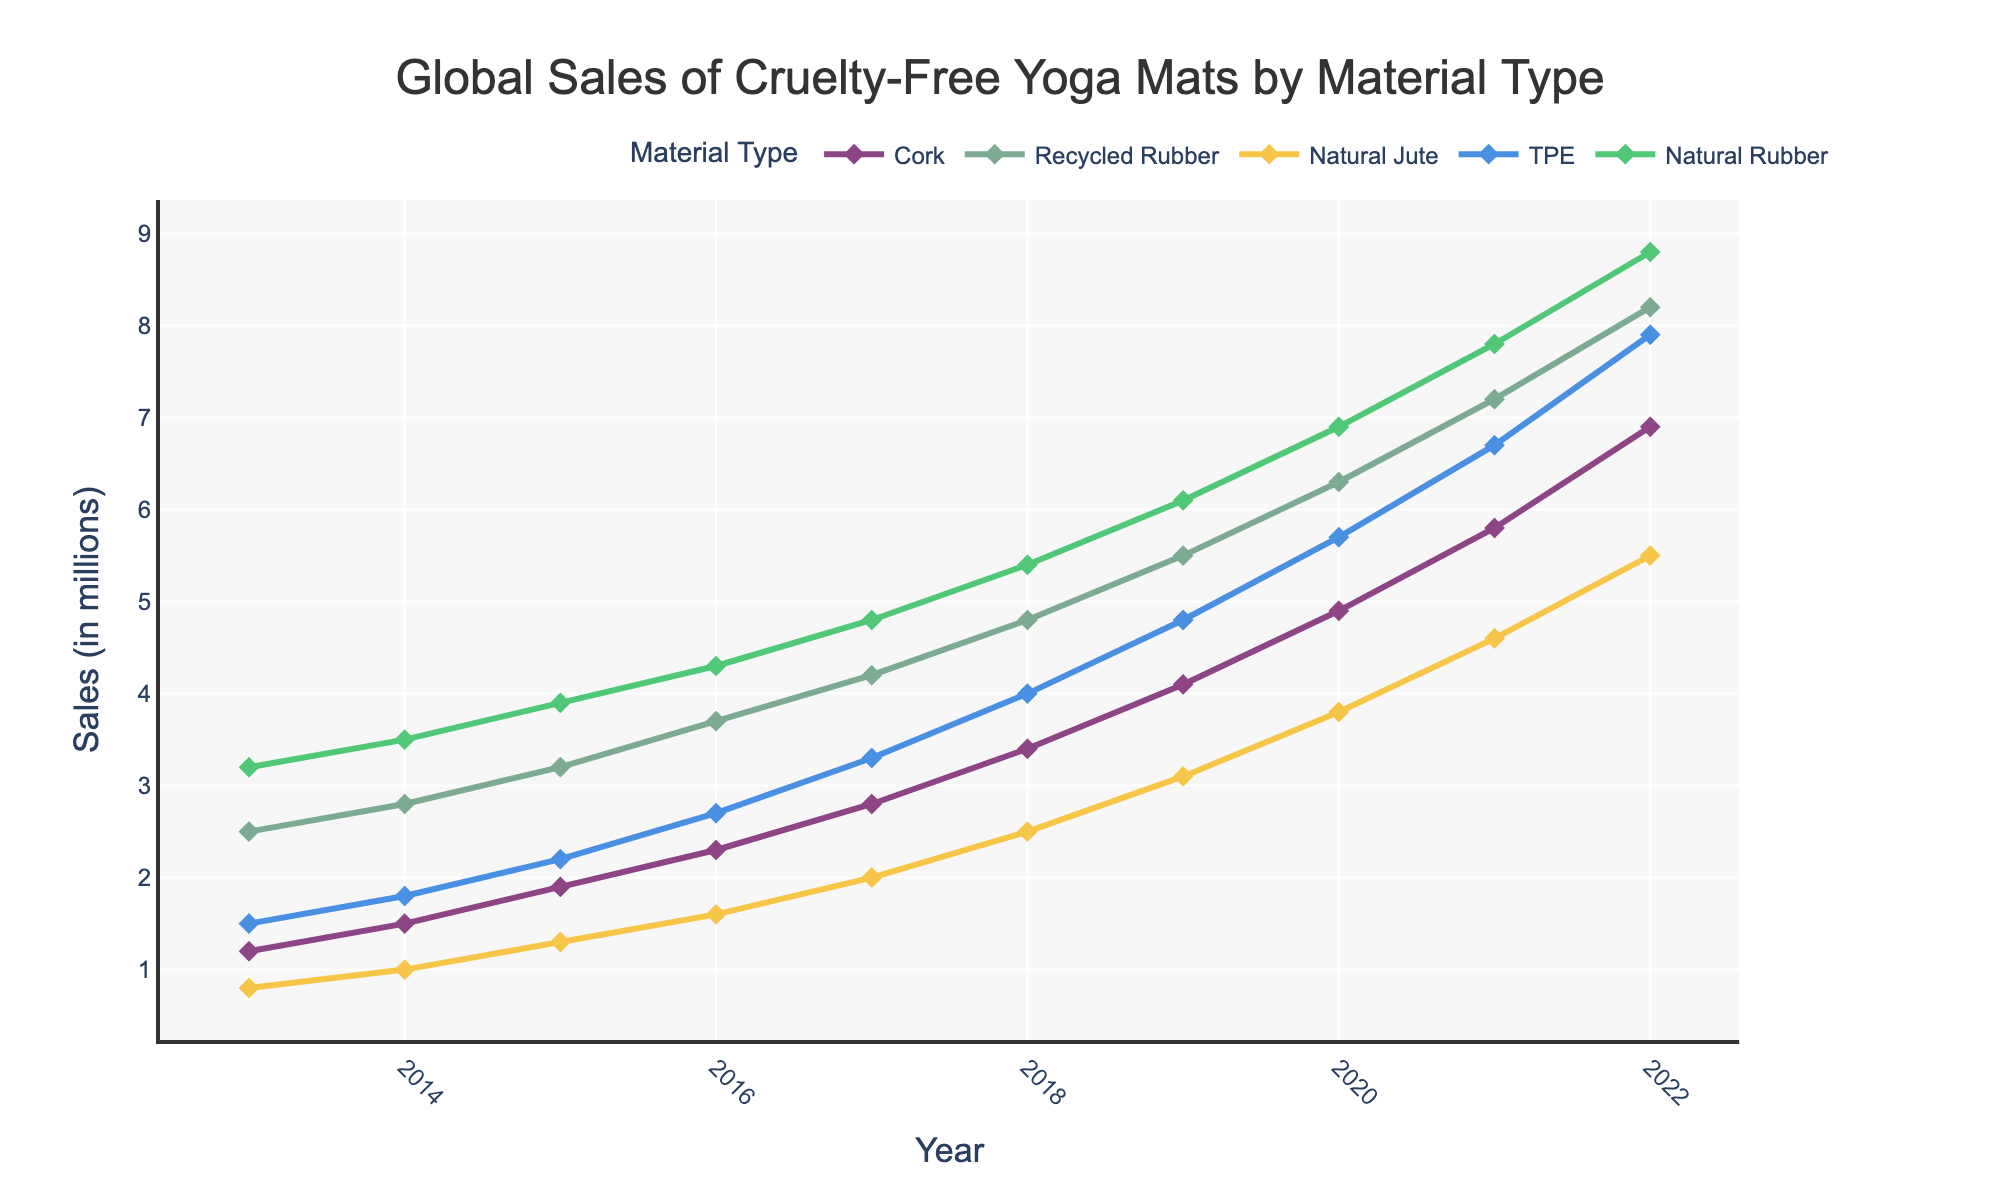What was the sales trend of TPE mats between 2013 and 2022? Examine the sales values for TPE mats in 2013 and 2022. In 2013, the sales were 1.5 million; by 2022, they had increased to 7.9 million. This indicates a consistent upward trend.
Answer: Increased consistently Which material type had the highest sales in 2022? Look at the sales value for each material type in 2022. Natural Rubber had sales of 8.8 million, which is higher than the other materials.
Answer: Natural Rubber How did the total sales of Cork mats in the last five years compare to the total sales of Recycled Rubber mats for the same period? Summing up the sales of Cork from 2018 to 2022 (3.4 + 4.1 + 4.9 + 5.8 + 6.9) gives 25.1 million, and summing up the sales of Recycled Rubber for the same years (4.8 + 5.5 + 6.3 + 7.2 + 8.2) gives 32.0 million. Therefore, Recycled Rubber had higher total sales.
Answer: Recycled Rubber had higher sales What notable visual trend do you observe in the sales of Natural Rubber between 2013 and 2022? The figure shows a steep upward trend in natural rubber sales, starting from 3.2 million in 2013 and reaching 8.8 million in 2022. The line on the graph is steeper compared to others, indicating a more rapid increase.
Answer: Steep upward trend Compare the sales growth rates of Cork and Natural Jute mats from 2018 to 2022. For Cork, the growth from 2018 (3.4 million) to 2022 (6.9 million) is 6.9 - 3.4 = 3.5 million. For Natural Jute, the growth from 2018 (2.5 million) to 2022 (5.5 million) is 5.5 - 2.5 = 3 million. Cork had a higher growth rate.
Answer: Cork had a higher growth rate Between 2016 and 2018, which material had the greatest absolute increase in sales? Calculate the difference in sales for each material between 2016 and 2018: Cork (3.4 - 2.3 = 1.1), Recycled Rubber (4.8 - 3.7 = 1.1), Natural Jute (2.5 - 1.6 = 0.9), TPE (4.0 - 2.7 = 1.3), Natural Rubber (5.4 - 4.3 = 1.1). TPE had the greatest increase.
Answer: TPE What was the sales gap between Recycled Rubber and Natural Jute mats in 2019? In 2019, sales for Recycled Rubber were 5.5 million, and for Natural Jute, it was 3.1 million. The sales gap is 5.5 - 3.1 = 2.4 million.
Answer: 2.4 million Which material had the least variability in sales over the decade? By visually examining the graph, Natural Jute has the flattest growth curve with smaller incremental increases compared to the other materials, indicating least variability.
Answer: Natural Jute If you were to average the sales of Cork and TPE mats in 2021, what would be the result? The sales of Cork in 2021 were 5.8 million, and for TPE, it was 6.7 million. The average is (5.8 + 6.7) / 2 = 6.25 million.
Answer: 6.25 million Which material saw the sharpest increase in sales from 2020 to 2021? The increase in sales from 2020 to 2021 for each material: Cork (5.8 - 4.9 = 0.9), Recycled Rubber (7.2 - 6.3 = 0.9), Natural Jute (4.6 - 3.8 = 0.8), TPE (6.7 - 5.7 = 1.0), Natural Rubber (7.8 - 6.9 = 0.9). TPE had the sharpest increase of 1.0 million.
Answer: TPE 